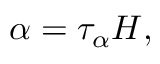Convert formula to latex. <formula><loc_0><loc_0><loc_500><loc_500>\alpha = \tau _ { \alpha } H ,</formula> 